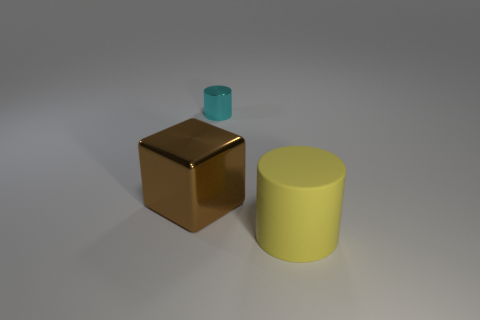Add 3 big blocks. How many objects exist? 6 Subtract all cylinders. How many objects are left? 1 Add 1 big blue metallic cubes. How many big blue metallic cubes exist? 1 Subtract 0 blue blocks. How many objects are left? 3 Subtract all large gray shiny things. Subtract all tiny objects. How many objects are left? 2 Add 2 small objects. How many small objects are left? 3 